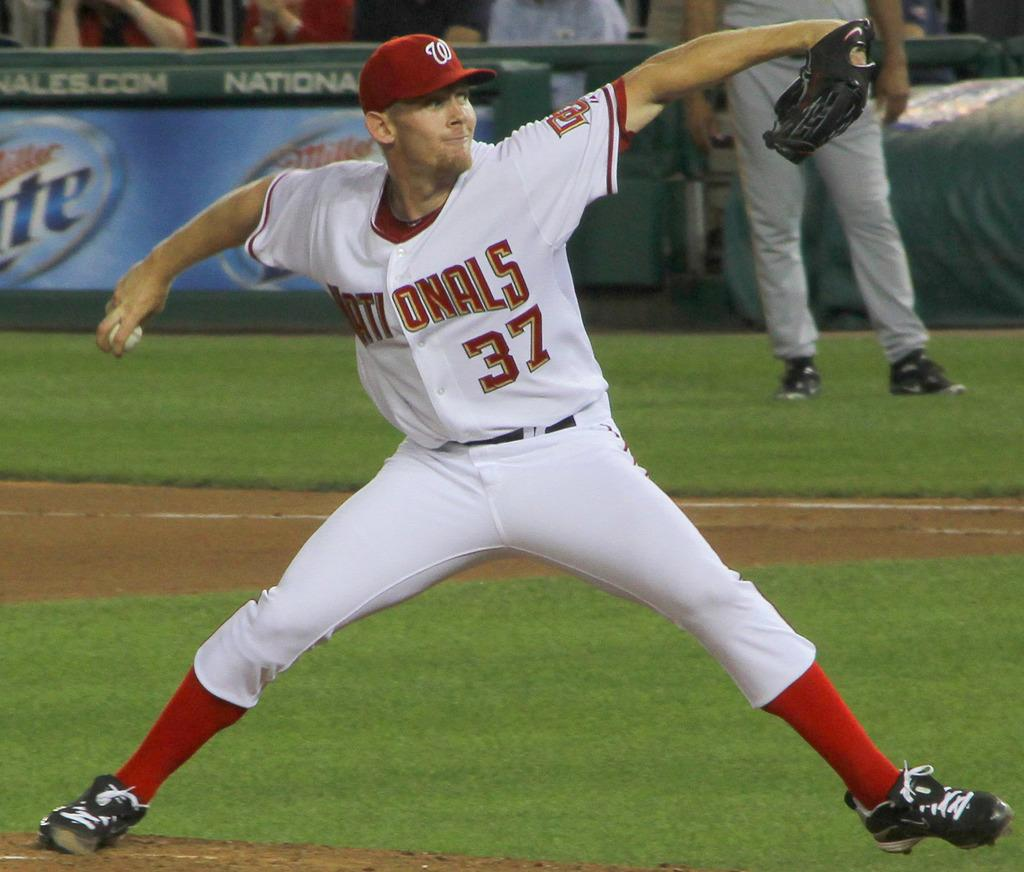<image>
Offer a succinct explanation of the picture presented. a Nationals player that has the number 37 on them 